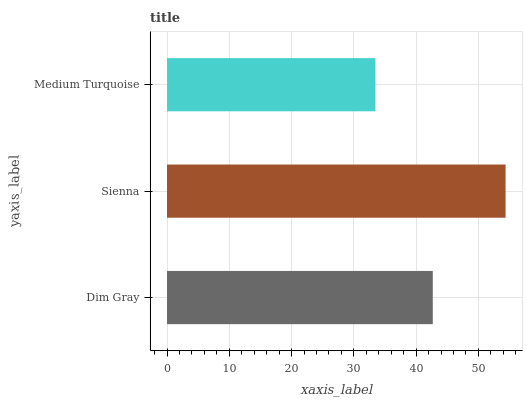Is Medium Turquoise the minimum?
Answer yes or no. Yes. Is Sienna the maximum?
Answer yes or no. Yes. Is Sienna the minimum?
Answer yes or no. No. Is Medium Turquoise the maximum?
Answer yes or no. No. Is Sienna greater than Medium Turquoise?
Answer yes or no. Yes. Is Medium Turquoise less than Sienna?
Answer yes or no. Yes. Is Medium Turquoise greater than Sienna?
Answer yes or no. No. Is Sienna less than Medium Turquoise?
Answer yes or no. No. Is Dim Gray the high median?
Answer yes or no. Yes. Is Dim Gray the low median?
Answer yes or no. Yes. Is Sienna the high median?
Answer yes or no. No. Is Medium Turquoise the low median?
Answer yes or no. No. 